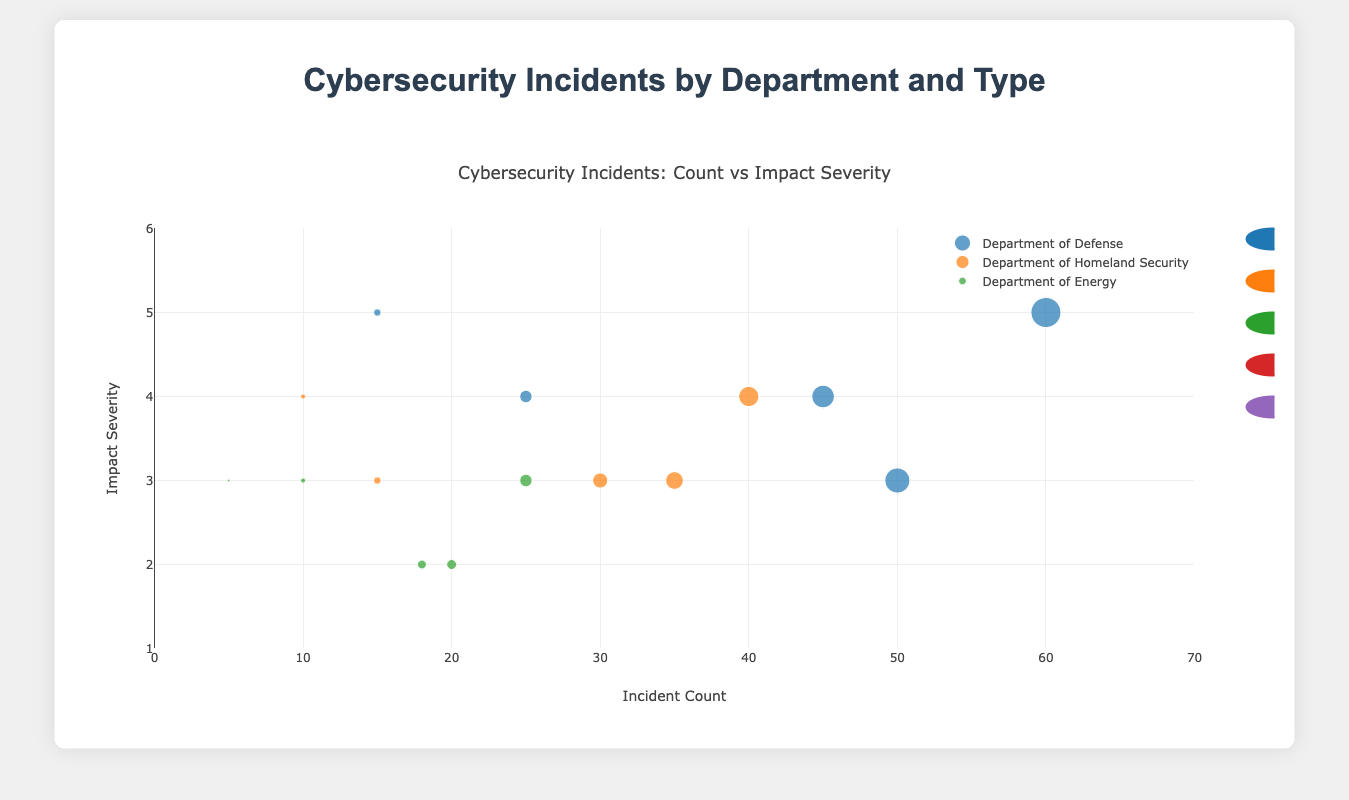What is the title of the figure? The title of the figure is typically found at the top center of the chart. It gives an overview of what the chart represents. In this case, the title of the figure is "Cybersecurity Incidents by Department and Type".
Answer: Cybersecurity Incidents by Department and Type What department has the highest number of incidents? To determine which department has the highest number of incidents, look for the department with the data points furthest to the right on the x-axis across all incident types. The Department of Defense has the highest count for several incident types (Malware: 60, Phishing: 45, Denial of Service: 50).
Answer: Department of Defense Which incident type has the highest impact severity overall? To find which incident type has the highest impact severity, observe the y-axis values for each incident type. Malware and Data Breach incidents in the Department of Defense both have an impact severity of 5, which is the highest.
Answer: Malware and Data Breach What is the number of Data Breach incidents in the Department of Homeland Security? Identify the data point representing the Department of Homeland Security for the Data Breach incident type and check its value on the x-axis. The number of Data Breach incidents in the Department of Homeland Security is 10.
Answer: 10 Compare the incident count and impact severity of Phishing across the Department of Defense and Department of Energy. Look at the data points for Phishing in both departments. For the Department of Defense, the incident count is 45 with an impact severity of 4. For the Department of Energy, the incident count is 20 with an impact severity of 2.
Answer: Department of Defense: 45 incidents, severity 4; Department of Energy: 20 incidents, severity 2 Which department has the highest severity for Denial of Service incidents? Examine the y-axis values for Denial of Service incidents across all departments. All departments (Department of Defense, Department of Homeland Security, and Department of Energy) have an impact severity of 3 for Denial of Service incidents.
Answer: None, all have equal severity Calculate the total number of Ransomware incidents across all departments. Sum the number of Ransomware incidents from each department: Department of Defense (25), Department of Homeland Security (15), and Department of Energy (10). The total is 25 + 15 + 10 = 50.
Answer: 50 How does the impact severity of Phishing compare to Malware in the Department of Homeland Security? Compare the y-axis values for Phishing and Malware in the Department of Homeland Security. The impact severity of Phishing is 3, whereas for Malware it is 4.
Answer: Malware has a higher severity (4) compared to Phishing (3) Which department has the least number of incidents for Data Breach, and how many incidents are there? Examine the x-axis values for Data Breach incidents across all departments. The Department of Energy has the least number of Data Breach incidents with a count of 5.
Answer: Department of Energy, 5 Among the incident types represented, which one has the most consistent impact severity across all departments? Consistency in impact severity can be determined by the y-axis values being the same across different departments. The Denial of Service incident type shows consistent impact severity (severity of 3) across all three departments.
Answer: Denial of Service 